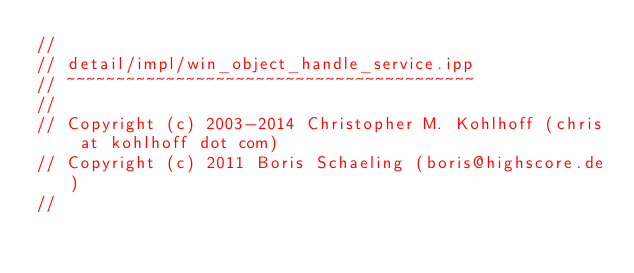<code> <loc_0><loc_0><loc_500><loc_500><_C++_>//
// detail/impl/win_object_handle_service.ipp
// ~~~~~~~~~~~~~~~~~~~~~~~~~~~~~~~~~~~~~~~~~
//
// Copyright (c) 2003-2014 Christopher M. Kohlhoff (chris at kohlhoff dot com)
// Copyright (c) 2011 Boris Schaeling (boris@highscore.de)
//</code> 